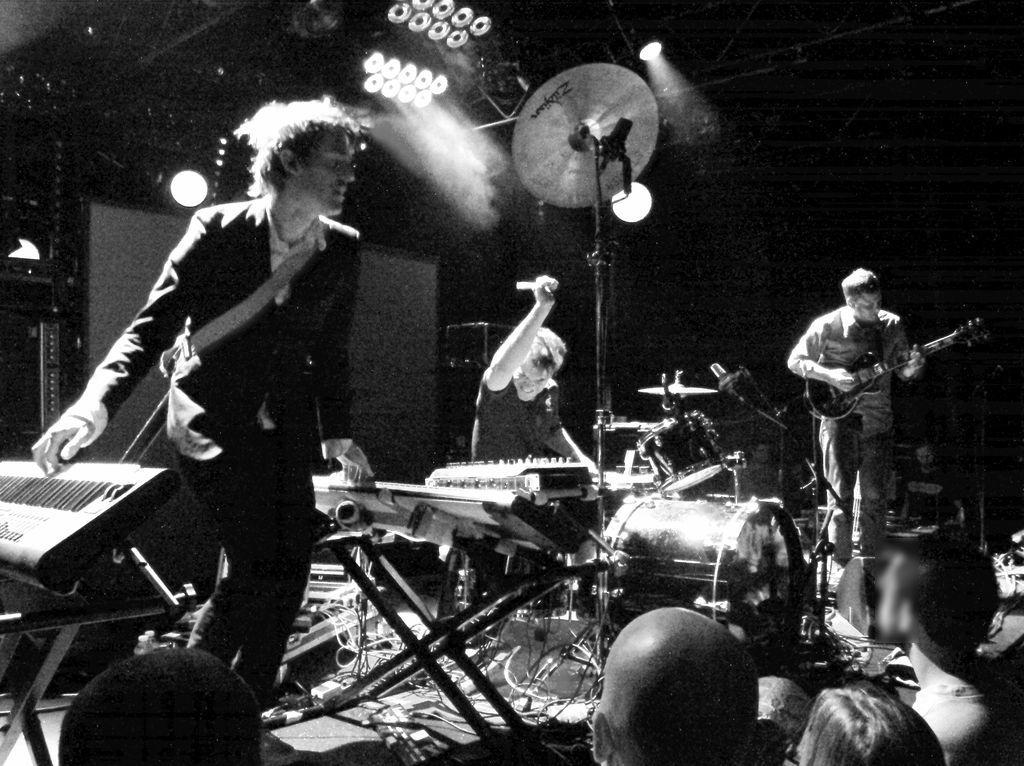What is the man on the left side of the image doing? The man on the left is playing a musical instrument. What type of musical instrument is the man on the left playing? The information provided does not specify the type of musical instrument the man on the left is playing. What is the man on the right side of the image doing? The man on the right is playing a guitar. How many quince are on the ground near the man playing the guitar? There is no mention of quince or any fruit in the image; it only features two men playing musical instruments. 